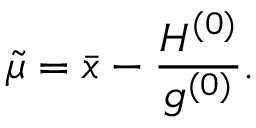<formula> <loc_0><loc_0><loc_500><loc_500>\tilde { \mu } = \bar { x } - \frac { H ^ { ( 0 ) } } { g ^ { ( 0 ) } } .</formula> 